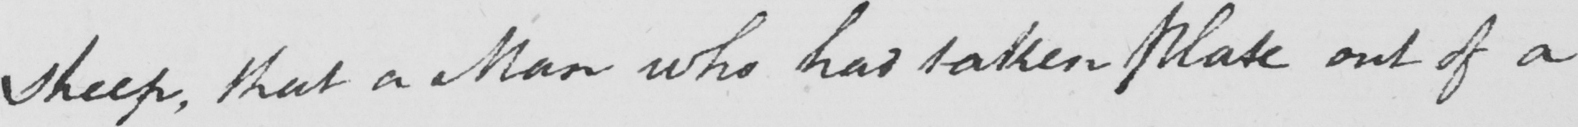What does this handwritten line say? Sheep , that a Man who had taken Plate out of a 